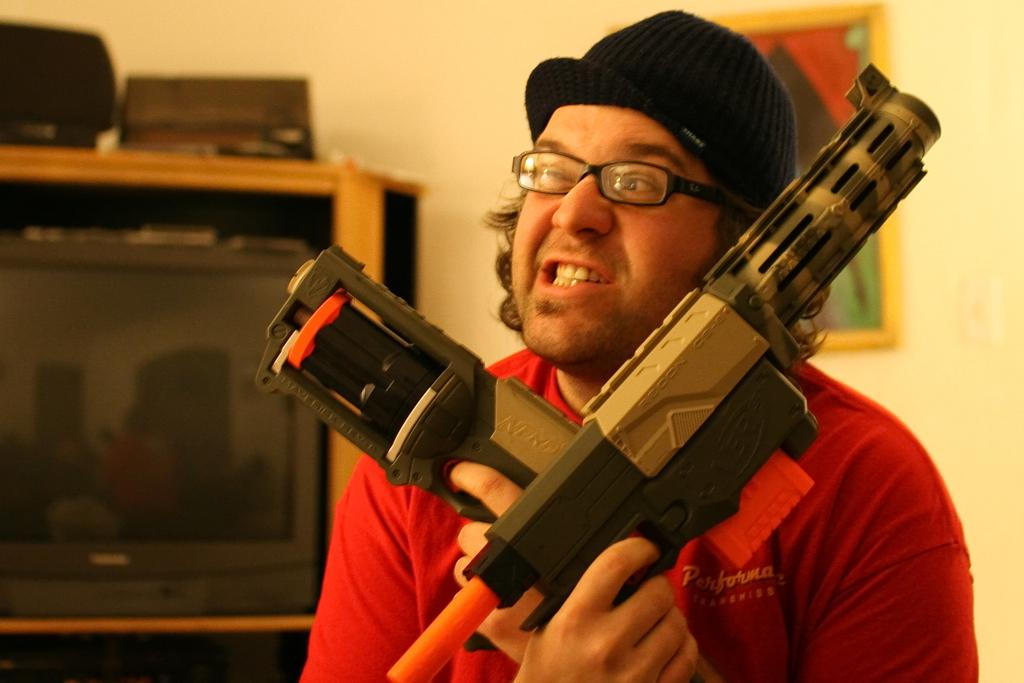Who is the main subject in the image? There is a man in the image. What is the man holding in the image? The man is holding two toy guns. What can be seen in the background of the image? There is a TV in the background of the image, and it is in a rack. What else is on the rack besides the TV? There are items on the rack. What is present on the wall in the background? There is a frame on the wall in the background. Can you tell me how many goldfish are swimming in the frame on the wall? There are no goldfish present in the image, and the frame on the wall does not depict any aquatic animals. 